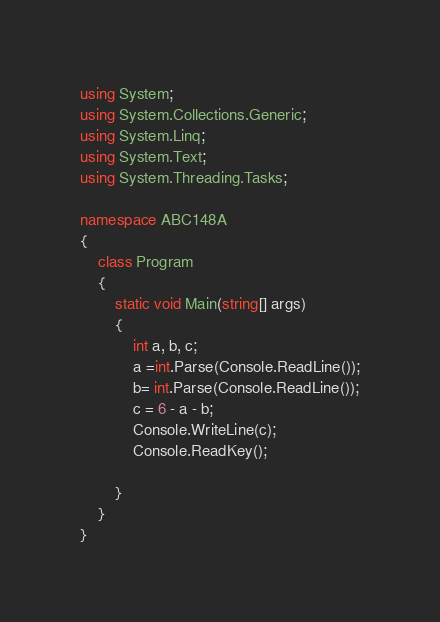<code> <loc_0><loc_0><loc_500><loc_500><_C#_>using System;
using System.Collections.Generic;
using System.Linq;
using System.Text;
using System.Threading.Tasks;

namespace ABC148A
{
    class Program
    {
        static void Main(string[] args)
        {
            int a, b, c;
            a =int.Parse(Console.ReadLine());
            b= int.Parse(Console.ReadLine());
            c = 6 - a - b;
            Console.WriteLine(c);
            Console.ReadKey();

        }
    }
}
</code> 